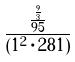<formula> <loc_0><loc_0><loc_500><loc_500>\frac { \frac { \frac { 9 } { 3 } } { 9 5 } } { ( 1 ^ { 2 } \cdot 2 8 1 ) }</formula> 